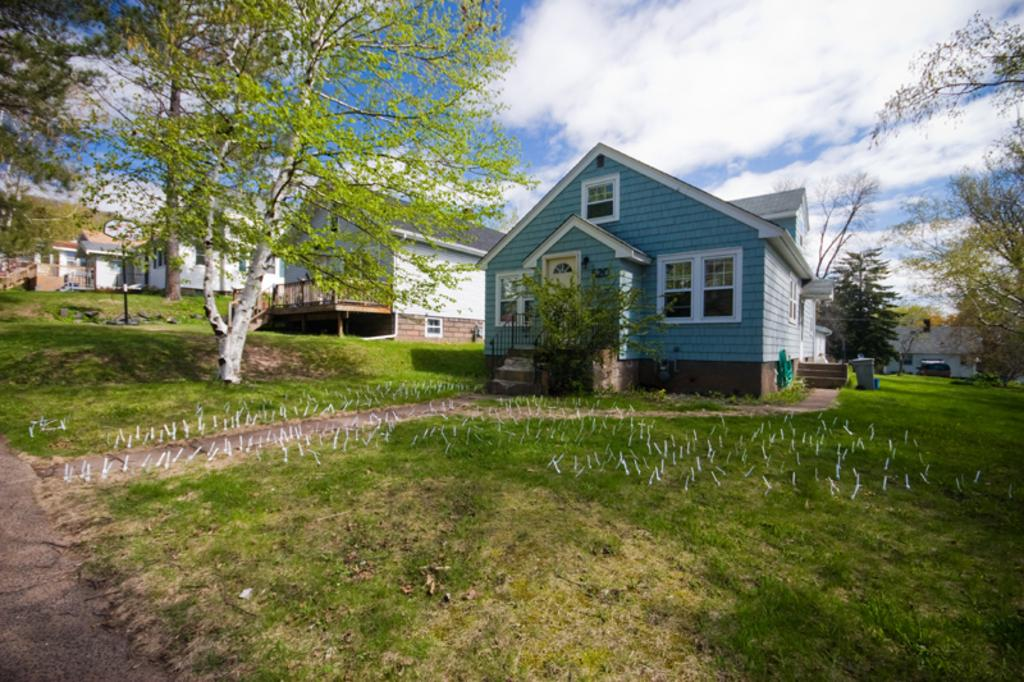What type of vegetation can be seen in the image? There is grass and trees in the image. What structures are visible in the image? There is a pole and houses in the image. What is visible in the background of the image? The sky is visible in the background of the image. What can be seen in the sky? Clouds are present in the sky. What type of dog can be seen reading a book in the image? There is no dog or book present in the image. What type of fruit is hanging from the trees in the image? The image does not show any fruit hanging from the trees; it only shows trees and grass. 